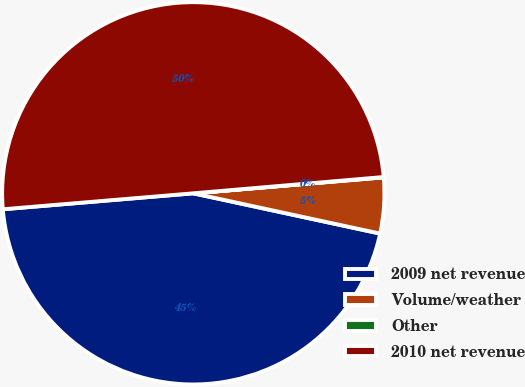Convert chart to OTSL. <chart><loc_0><loc_0><loc_500><loc_500><pie_chart><fcel>2009 net revenue<fcel>Volume/weather<fcel>Other<fcel>2010 net revenue<nl><fcel>45.29%<fcel>4.71%<fcel>0.03%<fcel>49.97%<nl></chart> 